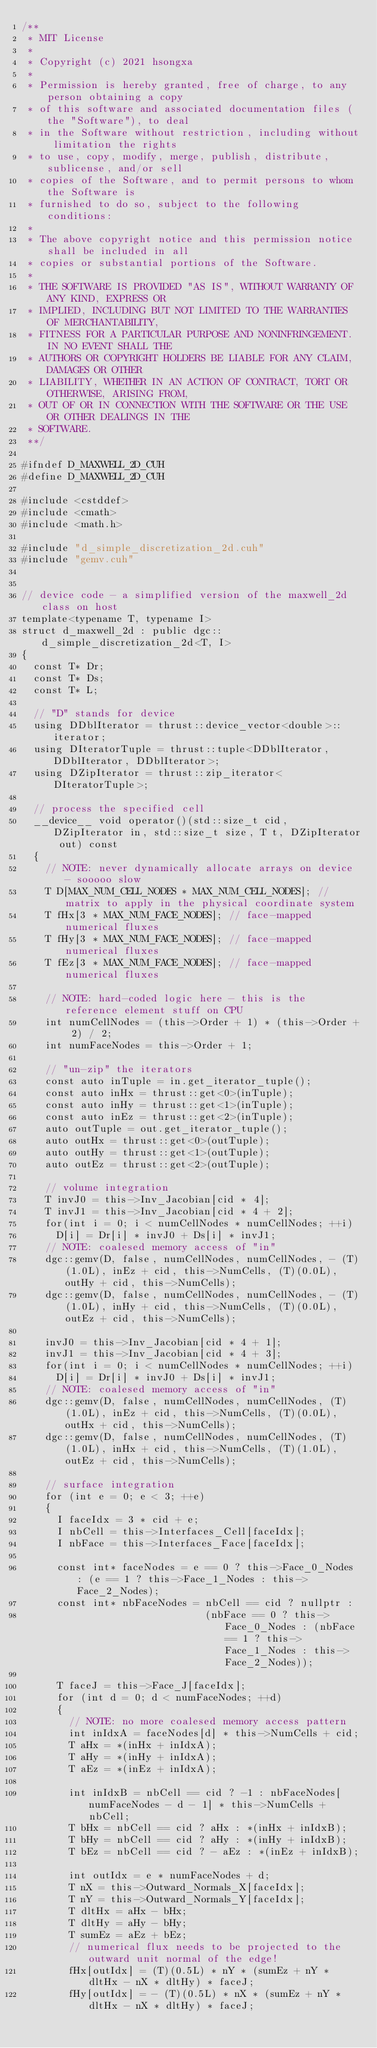Convert code to text. <code><loc_0><loc_0><loc_500><loc_500><_Cuda_>/**
 * MIT License
 * 
 * Copyright (c) 2021 hsongxa
 * 
 * Permission is hereby granted, free of charge, to any person obtaining a copy
 * of this software and associated documentation files (the "Software"), to deal
 * in the Software without restriction, including without limitation the rights
 * to use, copy, modify, merge, publish, distribute, sublicense, and/or sell
 * copies of the Software, and to permit persons to whom the Software is
 * furnished to do so, subject to the following conditions:
 * 
 * The above copyright notice and this permission notice shall be included in all
 * copies or substantial portions of the Software.
 * 
 * THE SOFTWARE IS PROVIDED "AS IS", WITHOUT WARRANTY OF ANY KIND, EXPRESS OR
 * IMPLIED, INCLUDING BUT NOT LIMITED TO THE WARRANTIES OF MERCHANTABILITY,
 * FITNESS FOR A PARTICULAR PURPOSE AND NONINFRINGEMENT. IN NO EVENT SHALL THE
 * AUTHORS OR COPYRIGHT HOLDERS BE LIABLE FOR ANY CLAIM, DAMAGES OR OTHER
 * LIABILITY, WHETHER IN AN ACTION OF CONTRACT, TORT OR OTHERWISE, ARISING FROM,
 * OUT OF OR IN CONNECTION WITH THE SOFTWARE OR THE USE OR OTHER DEALINGS IN THE
 * SOFTWARE.
 **/

#ifndef D_MAXWELL_2D_CUH
#define D_MAXWELL_2D_CUH

#include <cstddef>
#include <cmath>
#include <math.h>

#include "d_simple_discretization_2d.cuh"
#include "gemv.cuh"


// device code - a simplified version of the maxwell_2d class on host
template<typename T, typename I>
struct d_maxwell_2d : public dgc::d_simple_discretization_2d<T, I>
{
  const T* Dr;
  const T* Ds;
  const T* L;

  // "D" stands for device
  using DDblIterator = thrust::device_vector<double>::iterator;
  using DIteratorTuple = thrust::tuple<DDblIterator, DDblIterator, DDblIterator>;
  using DZipIterator = thrust::zip_iterator<DIteratorTuple>;

  // process the specified cell 
  __device__ void operator()(std::size_t cid, DZipIterator in, std::size_t size, T t, DZipIterator out) const
  {
    // NOTE: never dynamically allocate arrays on device - sooooo slow
    T D[MAX_NUM_CELL_NODES * MAX_NUM_CELL_NODES]; // matrix to apply in the physical coordinate system
    T fHx[3 * MAX_NUM_FACE_NODES]; // face-mapped numerical fluxes
    T fHy[3 * MAX_NUM_FACE_NODES]; // face-mapped numerical fluxes
    T fEz[3 * MAX_NUM_FACE_NODES]; // face-mapped numerical fluxes

    // NOTE: hard-coded logic here - this is the reference element stuff on CPU
    int numCellNodes = (this->Order + 1) * (this->Order + 2) / 2;
    int numFaceNodes = this->Order + 1;

    // "un-zip" the iterators
    const auto inTuple = in.get_iterator_tuple();
    const auto inHx = thrust::get<0>(inTuple);
    const auto inHy = thrust::get<1>(inTuple);
    const auto inEz = thrust::get<2>(inTuple);
    auto outTuple = out.get_iterator_tuple();
    auto outHx = thrust::get<0>(outTuple);
    auto outHy = thrust::get<1>(outTuple);
    auto outEz = thrust::get<2>(outTuple);

    // volume integration
    T invJ0 = this->Inv_Jacobian[cid * 4];
    T invJ1 = this->Inv_Jacobian[cid * 4 + 2];
    for(int i = 0; i < numCellNodes * numCellNodes; ++i)
      D[i] = Dr[i] * invJ0 + Ds[i] * invJ1; 
    // NOTE: coalesed memory access of "in"
    dgc::gemv(D, false, numCellNodes, numCellNodes, - (T)(1.0L), inEz + cid, this->NumCells, (T)(0.0L), outHy + cid, this->NumCells);
    dgc::gemv(D, false, numCellNodes, numCellNodes, - (T)(1.0L), inHy + cid, this->NumCells, (T)(0.0L), outEz + cid, this->NumCells);

    invJ0 = this->Inv_Jacobian[cid * 4 + 1];
    invJ1 = this->Inv_Jacobian[cid * 4 + 3];
    for(int i = 0; i < numCellNodes * numCellNodes; ++i)
      D[i] = Dr[i] * invJ0 + Ds[i] * invJ1; 
    // NOTE: coalesed memory access of "in"
    dgc::gemv(D, false, numCellNodes, numCellNodes, (T)(1.0L), inEz + cid, this->NumCells, (T)(0.0L), outHx + cid, this->NumCells);
    dgc::gemv(D, false, numCellNodes, numCellNodes, (T)(1.0L), inHx + cid, this->NumCells, (T)(1.0L), outEz + cid, this->NumCells);

    // surface integration
    for (int e = 0; e < 3; ++e)
    {
      I faceIdx = 3 * cid + e;
      I nbCell = this->Interfaces_Cell[faceIdx];
      I nbFace = this->Interfaces_Face[faceIdx];

      const int* faceNodes = e == 0 ? this->Face_0_Nodes : (e == 1 ? this->Face_1_Nodes : this->Face_2_Nodes);
      const int* nbFaceNodes = nbCell == cid ? nullptr : 
                               (nbFace == 0 ? this->Face_0_Nodes : (nbFace == 1 ? this->Face_1_Nodes : this->Face_2_Nodes));

      T faceJ = this->Face_J[faceIdx];
      for (int d = 0; d < numFaceNodes; ++d)
      {
        // NOTE: no more coalesed memory access pattern
        int inIdxA = faceNodes[d] * this->NumCells + cid;
        T aHx = *(inHx + inIdxA);
        T aHy = *(inHy + inIdxA);
        T aEz = *(inEz + inIdxA);

        int inIdxB = nbCell == cid ? -1 : nbFaceNodes[numFaceNodes - d - 1] * this->NumCells + nbCell;
        T bHx = nbCell == cid ? aHx : *(inHx + inIdxB);
        T bHy = nbCell == cid ? aHy : *(inHy + inIdxB);
        T bEz = nbCell == cid ? - aEz : *(inEz + inIdxB);

        int outIdx = e * numFaceNodes + d;
        T nX = this->Outward_Normals_X[faceIdx];
        T nY = this->Outward_Normals_Y[faceIdx];
        T dltHx = aHx - bHx;
        T dltHy = aHy - bHy;
        T sumEz = aEz + bEz;
        // numerical flux needs to be projected to the outward unit normal of the edge!
        fHx[outIdx] = (T)(0.5L) * nY * (sumEz + nY * dltHx - nX * dltHy) * faceJ;
        fHy[outIdx] = - (T)(0.5L) * nX * (sumEz + nY * dltHx - nX * dltHy) * faceJ;</code> 